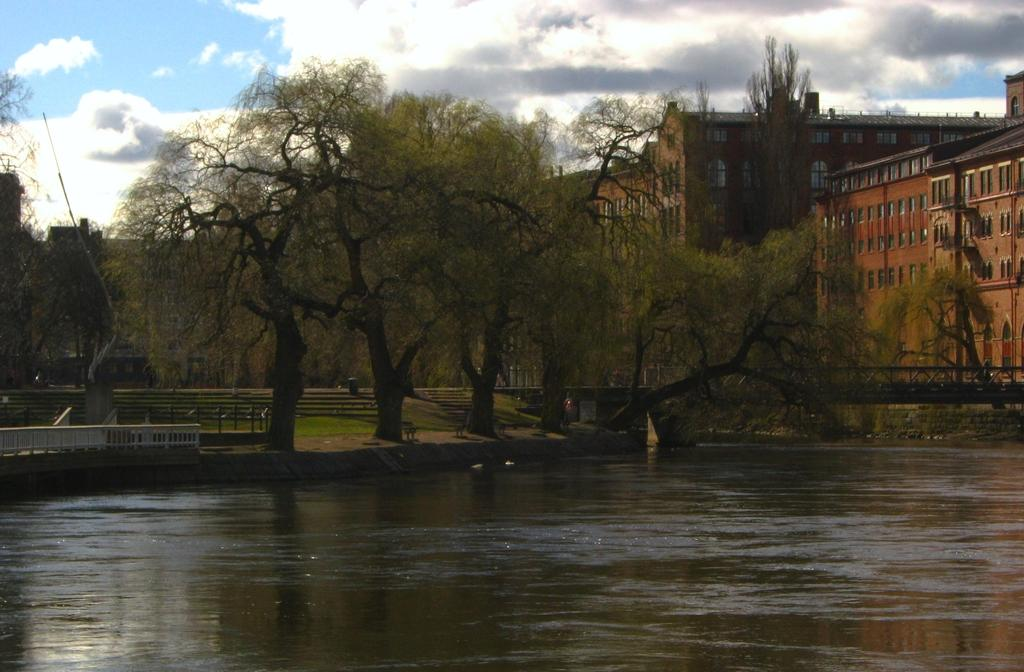What is the primary element visible in the image? There is water in the image. Can you describe the trees in the image? There are trees in the image, with some being green and others black in color. What can be seen on the ground in the image? The ground is visible in the image. What type of structure can be seen in the image? There is railing in the image. What else is present in the image besides the water and trees? There are buildings in the image. What is visible in the background of the image? The sky is visible in the background of the image. What type of crib can be seen floating on the water in the image? There is no crib present in the image; it features water, trees, railing, buildings, and the sky. What type of voice can be heard coming from the trees in the image? There is no voice present in the image; it is a visual representation of water, trees, railing, buildings, and the sky. 